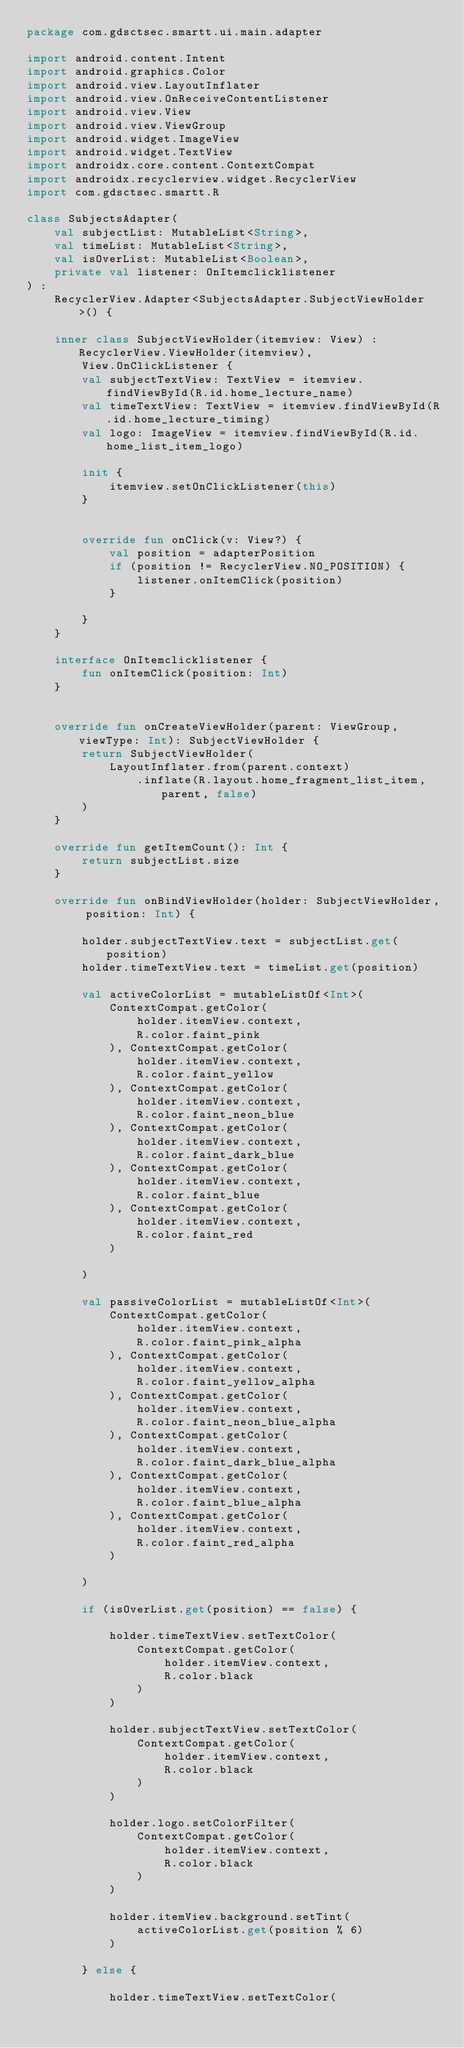<code> <loc_0><loc_0><loc_500><loc_500><_Kotlin_>package com.gdsctsec.smartt.ui.main.adapter

import android.content.Intent
import android.graphics.Color
import android.view.LayoutInflater
import android.view.OnReceiveContentListener
import android.view.View
import android.view.ViewGroup
import android.widget.ImageView
import android.widget.TextView
import androidx.core.content.ContextCompat
import androidx.recyclerview.widget.RecyclerView
import com.gdsctsec.smartt.R

class SubjectsAdapter(
    val subjectList: MutableList<String>,
    val timeList: MutableList<String>,
    val isOverList: MutableList<Boolean>,
    private val listener: OnItemclicklistener
) :
    RecyclerView.Adapter<SubjectsAdapter.SubjectViewHolder>() {

    inner class SubjectViewHolder(itemview: View) : RecyclerView.ViewHolder(itemview),
        View.OnClickListener {
        val subjectTextView: TextView = itemview.findViewById(R.id.home_lecture_name)
        val timeTextView: TextView = itemview.findViewById(R.id.home_lecture_timing)
        val logo: ImageView = itemview.findViewById(R.id.home_list_item_logo)

        init {
            itemview.setOnClickListener(this)
        }


        override fun onClick(v: View?) {
            val position = adapterPosition
            if (position != RecyclerView.NO_POSITION) {
                listener.onItemClick(position)
            }

        }
    }

    interface OnItemclicklistener {
        fun onItemClick(position: Int)
    }


    override fun onCreateViewHolder(parent: ViewGroup, viewType: Int): SubjectViewHolder {
        return SubjectViewHolder(
            LayoutInflater.from(parent.context)
                .inflate(R.layout.home_fragment_list_item, parent, false)
        )
    }

    override fun getItemCount(): Int {
        return subjectList.size
    }

    override fun onBindViewHolder(holder: SubjectViewHolder, position: Int) {

        holder.subjectTextView.text = subjectList.get(position)
        holder.timeTextView.text = timeList.get(position)

        val activeColorList = mutableListOf<Int>(
            ContextCompat.getColor(
                holder.itemView.context,
                R.color.faint_pink
            ), ContextCompat.getColor(
                holder.itemView.context,
                R.color.faint_yellow
            ), ContextCompat.getColor(
                holder.itemView.context,
                R.color.faint_neon_blue
            ), ContextCompat.getColor(
                holder.itemView.context,
                R.color.faint_dark_blue
            ), ContextCompat.getColor(
                holder.itemView.context,
                R.color.faint_blue
            ), ContextCompat.getColor(
                holder.itemView.context,
                R.color.faint_red
            )

        )

        val passiveColorList = mutableListOf<Int>(
            ContextCompat.getColor(
                holder.itemView.context,
                R.color.faint_pink_alpha
            ), ContextCompat.getColor(
                holder.itemView.context,
                R.color.faint_yellow_alpha
            ), ContextCompat.getColor(
                holder.itemView.context,
                R.color.faint_neon_blue_alpha
            ), ContextCompat.getColor(
                holder.itemView.context,
                R.color.faint_dark_blue_alpha
            ), ContextCompat.getColor(
                holder.itemView.context,
                R.color.faint_blue_alpha
            ), ContextCompat.getColor(
                holder.itemView.context,
                R.color.faint_red_alpha
            )

        )

        if (isOverList.get(position) == false) {

            holder.timeTextView.setTextColor(
                ContextCompat.getColor(
                    holder.itemView.context,
                    R.color.black
                )
            )

            holder.subjectTextView.setTextColor(
                ContextCompat.getColor(
                    holder.itemView.context,
                    R.color.black
                )
            )

            holder.logo.setColorFilter(
                ContextCompat.getColor(
                    holder.itemView.context,
                    R.color.black
                )
            )

            holder.itemView.background.setTint(
                activeColorList.get(position % 6)
            )

        } else {

            holder.timeTextView.setTextColor(</code> 